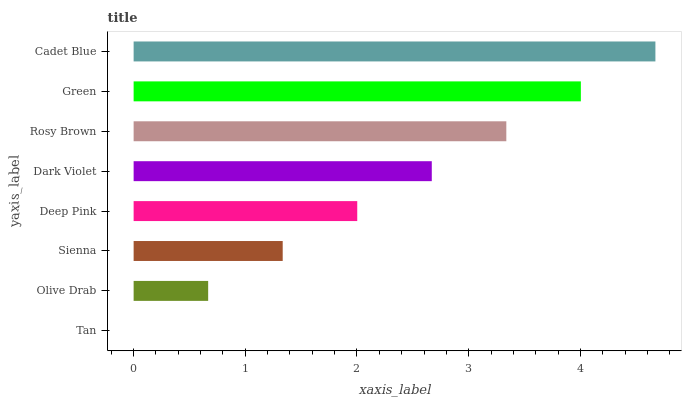Is Tan the minimum?
Answer yes or no. Yes. Is Cadet Blue the maximum?
Answer yes or no. Yes. Is Olive Drab the minimum?
Answer yes or no. No. Is Olive Drab the maximum?
Answer yes or no. No. Is Olive Drab greater than Tan?
Answer yes or no. Yes. Is Tan less than Olive Drab?
Answer yes or no. Yes. Is Tan greater than Olive Drab?
Answer yes or no. No. Is Olive Drab less than Tan?
Answer yes or no. No. Is Dark Violet the high median?
Answer yes or no. Yes. Is Deep Pink the low median?
Answer yes or no. Yes. Is Cadet Blue the high median?
Answer yes or no. No. Is Dark Violet the low median?
Answer yes or no. No. 